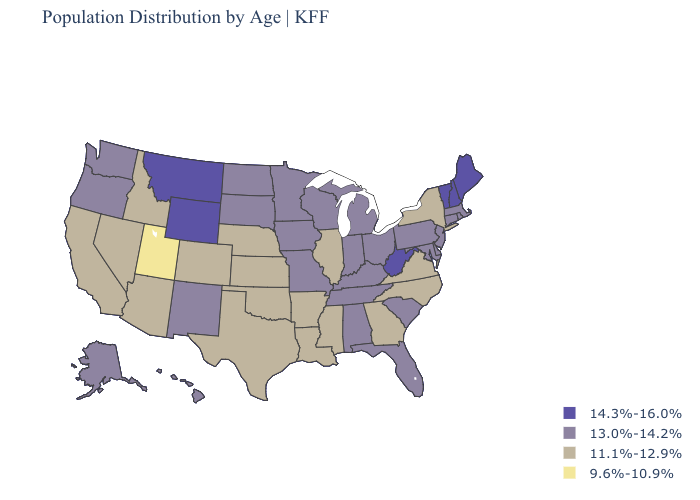Does Mississippi have a higher value than Maine?
Concise answer only. No. Name the states that have a value in the range 13.0%-14.2%?
Short answer required. Alabama, Alaska, Connecticut, Delaware, Florida, Hawaii, Indiana, Iowa, Kentucky, Maryland, Massachusetts, Michigan, Minnesota, Missouri, New Jersey, New Mexico, North Dakota, Ohio, Oregon, Pennsylvania, Rhode Island, South Carolina, South Dakota, Tennessee, Washington, Wisconsin. Which states hav the highest value in the South?
Be succinct. West Virginia. Does Nevada have a lower value than Arkansas?
Write a very short answer. No. Which states hav the highest value in the West?
Keep it brief. Montana, Wyoming. Name the states that have a value in the range 13.0%-14.2%?
Answer briefly. Alabama, Alaska, Connecticut, Delaware, Florida, Hawaii, Indiana, Iowa, Kentucky, Maryland, Massachusetts, Michigan, Minnesota, Missouri, New Jersey, New Mexico, North Dakota, Ohio, Oregon, Pennsylvania, Rhode Island, South Carolina, South Dakota, Tennessee, Washington, Wisconsin. What is the value of Minnesota?
Short answer required. 13.0%-14.2%. Does California have a lower value than Idaho?
Quick response, please. No. What is the value of Tennessee?
Keep it brief. 13.0%-14.2%. Is the legend a continuous bar?
Write a very short answer. No. Does Florida have a higher value than Michigan?
Write a very short answer. No. What is the value of Oregon?
Be succinct. 13.0%-14.2%. Among the states that border Wisconsin , which have the lowest value?
Quick response, please. Illinois. Which states have the highest value in the USA?
Keep it brief. Maine, Montana, New Hampshire, Vermont, West Virginia, Wyoming. What is the value of Illinois?
Give a very brief answer. 11.1%-12.9%. 